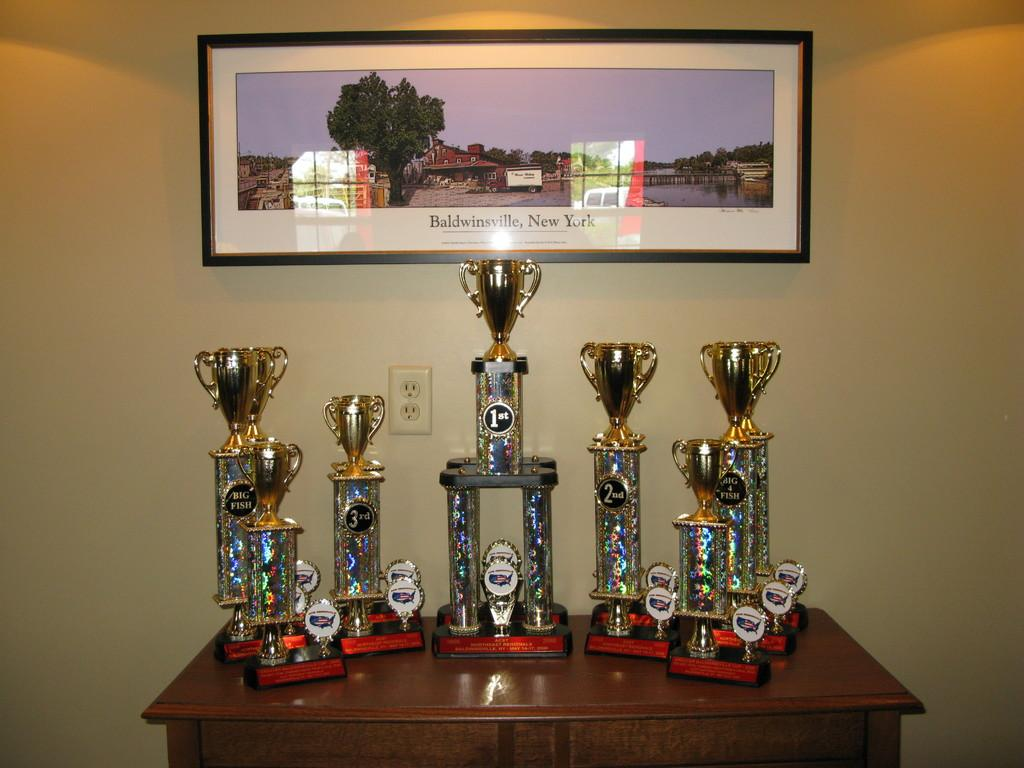What is placed on the wooden table in the image? There are awards placed on a wooden table in the image. What can be seen in the background of the image? There is a wall visible in the background. What is on the wall in the image? The wall has a photo frame and lights visible on it. What type of silk fabric is draped over the awards in the image? There is no silk fabric present in the image; the awards are placed directly on the wooden table. 